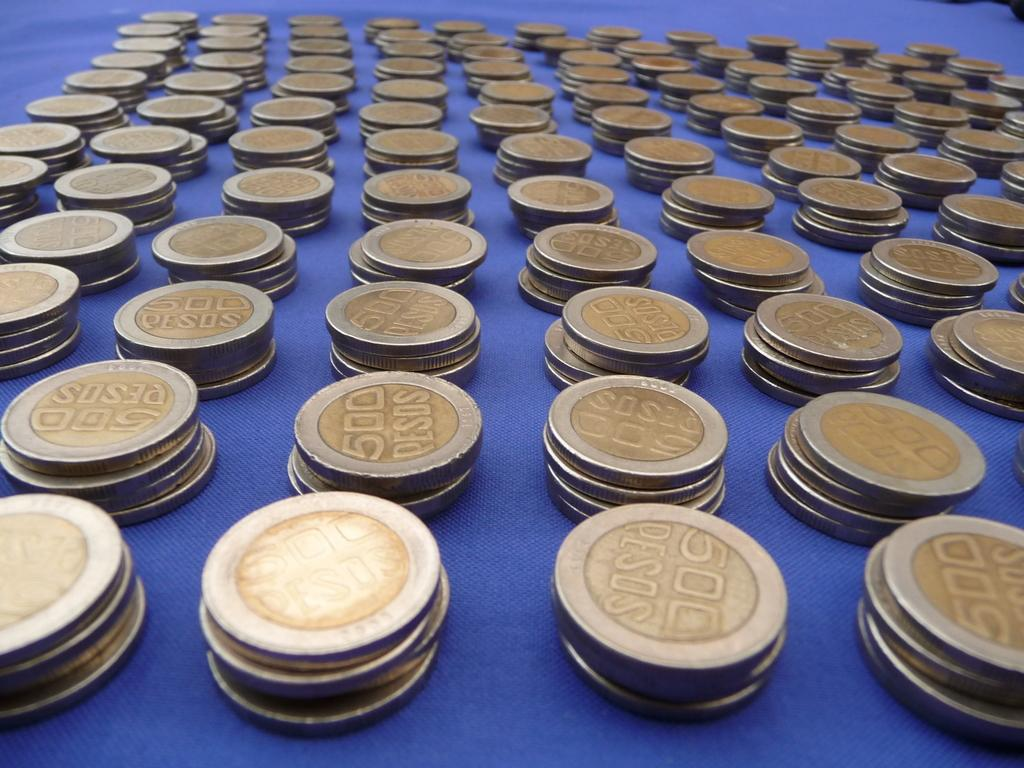Provide a one-sentence caption for the provided image. Several stacks of 500 peso coins are on top of a blue surface. 